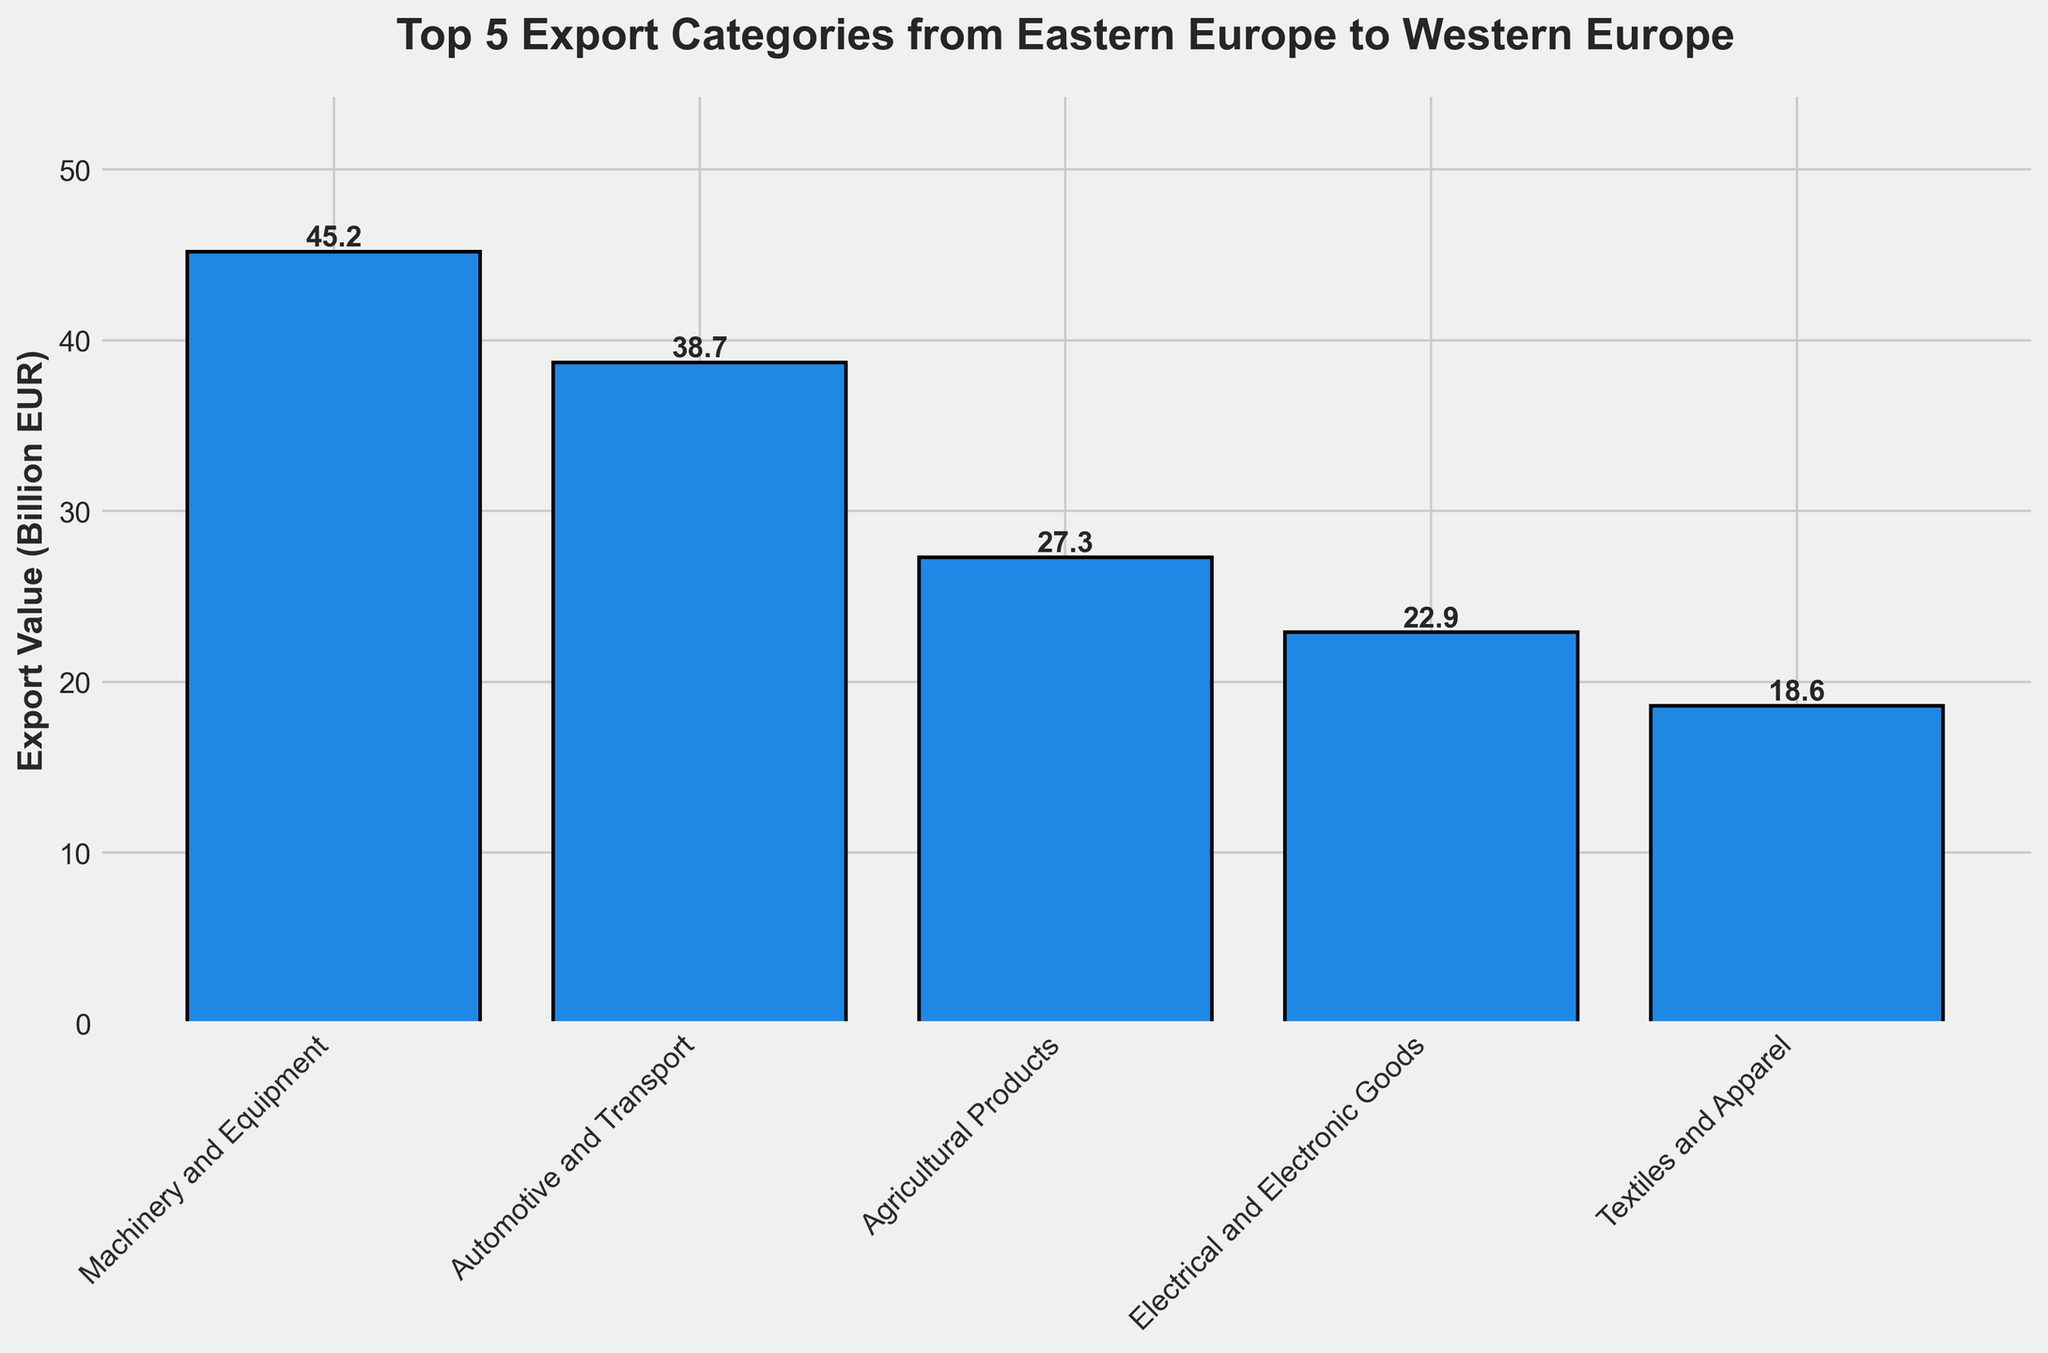Which category has the highest export value? The category with the highest bar represents the highest export value. In the chart, the Machinery and Equipment bar is the tallest.
Answer: Machinery and Equipment How much more do Machinery and Equipment exports value than Textiles and Apparel? Find the export values of both categories in the chart. Machinery and Equipment is 45.2 billion EUR, and Textiles and Apparel is 18.6 billion EUR. Calculate the difference: 45.2 - 18.6.
Answer: 26.6 billion EUR What is the combined export value of Automotive and Transport and Electrical and Electronic Goods? Find the export values of both categories (38.7 billion EUR for Automotive and Transport and 22.9 billion EUR for Electrical and Electronic Goods). Add them together: 38.7 + 22.9.
Answer: 61.6 billion EUR Which export category is the third highest? Identify the top three highest bars and order them from highest to lowest. The tallest is Machinery and Equipment, followed by Automotive and Transport. The third highest is Agricultural Products.
Answer: Agricultural Products Do Agricultural Products or Electrical and Electronic Goods have a higher export value? Compare the bar heights or the export values directly from the chart. Agricultural Products is 27.3 billion EUR, and Electrical and Electronic Goods is 22.9 billion EUR.
Answer: Agricultural Products What is the average export value of all five categories? Find the export values of all categories (45.2, 38.7, 27.3, 22.9, and 18.6 billion EUR). Calculate the sum: 45.2 + 38.7 + 27.3 + 22.9 + 18.6. Then, divide by 5 (number of categories): 152.7 / 5.
Answer: 30.54 billion EUR How much more does the largest export category contribute than the smallest? Identify the largest (Machinery and Equipment: 45.2 billion EUR) and the smallest (Textiles and Apparel: 18.6 billion EUR). Calculate the difference: 45.2 - 18.6.
Answer: 26.6 billion EUR Which export category represents the least value and by how much does it differ from the category with the highest value? Determine the categories with the least (Textiles and Apparel: 18.6 billion EUR) and the highest value (Machinery and Equipment: 45.2 billion EUR). Calculate the difference: 45.2 - 18.6.
Answer: Textiles and Apparel, 26.6 billion EUR What percent of total exports do Agricultural Products represent? Find the export value of Agricultural Products (27.3 billion EUR) and the total export value of all categories (sum of 45.2, 38.7, 27.3, 22.9, and 18.6 billion EUR). Calculate the percent: (27.3 / 152.7) * 100.
Answer: 17.9% Is the export value for Electrical and Electronic Goods closer to that for Automotive and Transport or Textiles and Apparel? Compare the export values: Electrical and Electronic Goods (22.9 billion EUR), Automotive and Transport (38.7 billion EUR), and Textiles and Apparel (18.6 billion EUR). Calculate the differences:
Answer: Automotive and Transport at 15.8 billion EUR (closest) 